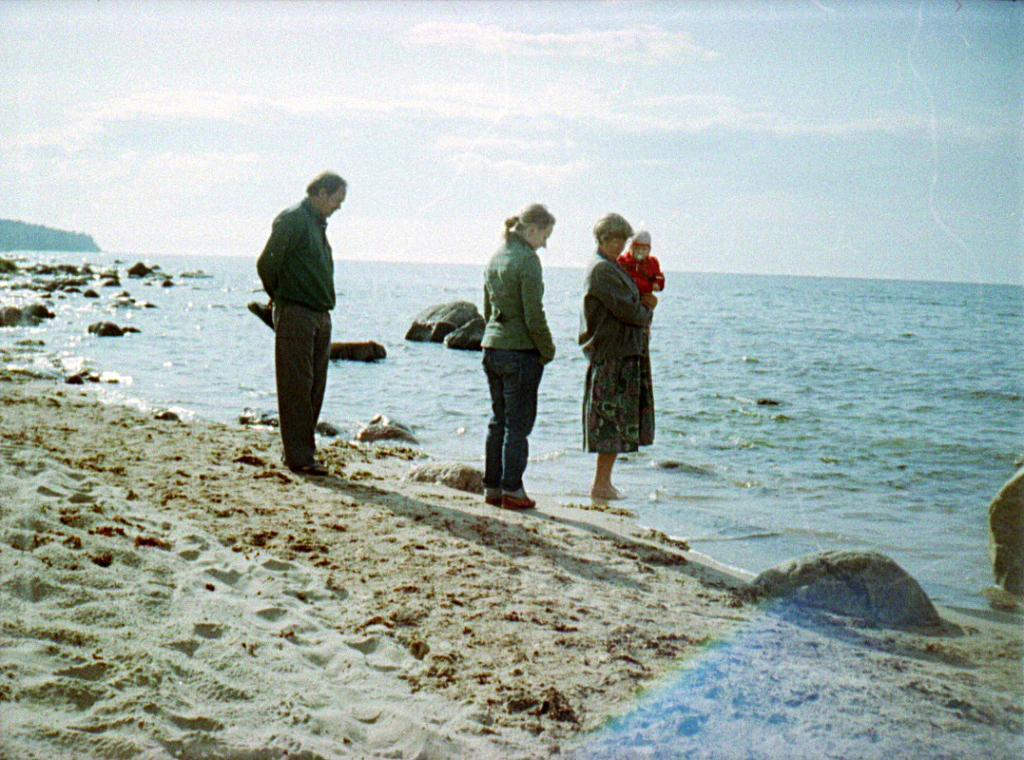How would you summarize this image in a sentence or two? In this image we can see a group of people standing on the ground. One woman is holding a baby with her hands. In the background, we can see a group of rocks, water and the cloudy sky. 